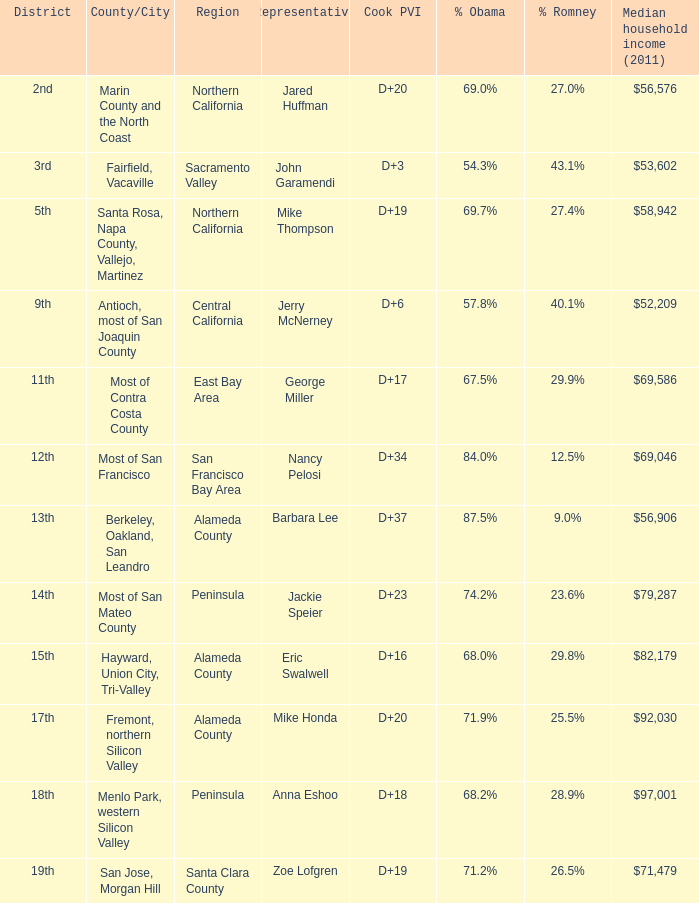Can you give me this table as a dict? {'header': ['District', 'County/City', 'Region', 'Representative', 'Cook PVI', '% Obama', '% Romney', 'Median household income (2011)'], 'rows': [['2nd', 'Marin County and the North Coast', 'Northern California', 'Jared Huffman', 'D+20', '69.0%', '27.0%', '$56,576'], ['3rd', 'Fairfield, Vacaville', 'Sacramento Valley', 'John Garamendi', 'D+3', '54.3%', '43.1%', '$53,602'], ['5th', 'Santa Rosa, Napa County, Vallejo, Martinez', 'Northern California', 'Mike Thompson', 'D+19', '69.7%', '27.4%', '$58,942'], ['9th', 'Antioch, most of San Joaquin County', 'Central California', 'Jerry McNerney', 'D+6', '57.8%', '40.1%', '$52,209'], ['11th', 'Most of Contra Costa County', 'East Bay Area', 'George Miller', 'D+17', '67.5%', '29.9%', '$69,586'], ['12th', 'Most of San Francisco', 'San Francisco Bay Area', 'Nancy Pelosi', 'D+34', '84.0%', '12.5%', '$69,046'], ['13th', 'Berkeley, Oakland, San Leandro', 'Alameda County', 'Barbara Lee', 'D+37', '87.5%', '9.0%', '$56,906'], ['14th', 'Most of San Mateo County', 'Peninsula', 'Jackie Speier', 'D+23', '74.2%', '23.6%', '$79,287'], ['15th', 'Hayward, Union City, Tri-Valley', 'Alameda County', 'Eric Swalwell', 'D+16', '68.0%', '29.8%', '$82,179'], ['17th', 'Fremont, northern Silicon Valley', 'Alameda County', 'Mike Honda', 'D+20', '71.9%', '25.5%', '$92,030'], ['18th', 'Menlo Park, western Silicon Valley', 'Peninsula', 'Anna Eshoo', 'D+18', '68.2%', '28.9%', '$97,001'], ['19th', 'San Jose, Morgan Hill', 'Santa Clara County', 'Zoe Lofgren', 'D+19', '71.2%', '26.5%', '$71,479']]} What is the Cook PVI for the location that has a representative of Mike Thompson? D+19. 